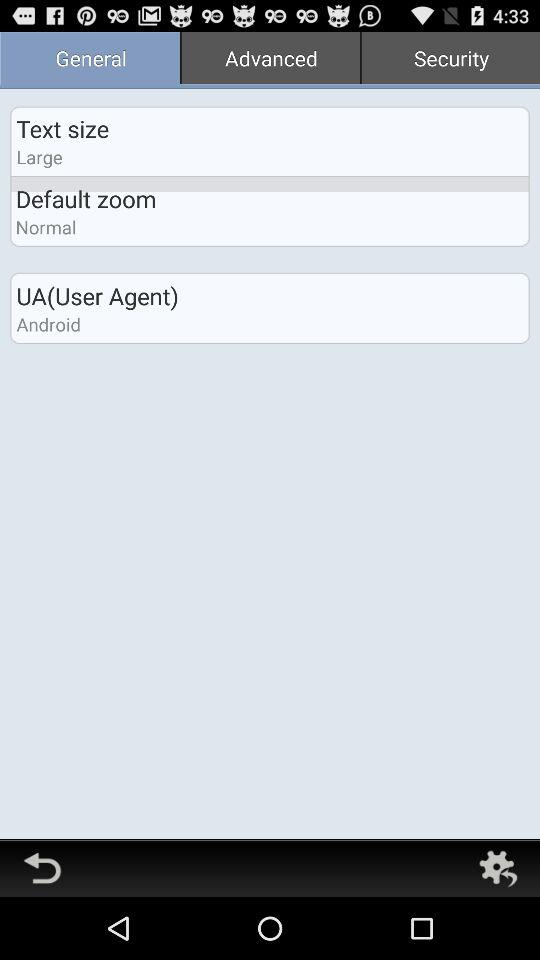What is the text size? The text size is "Large". 